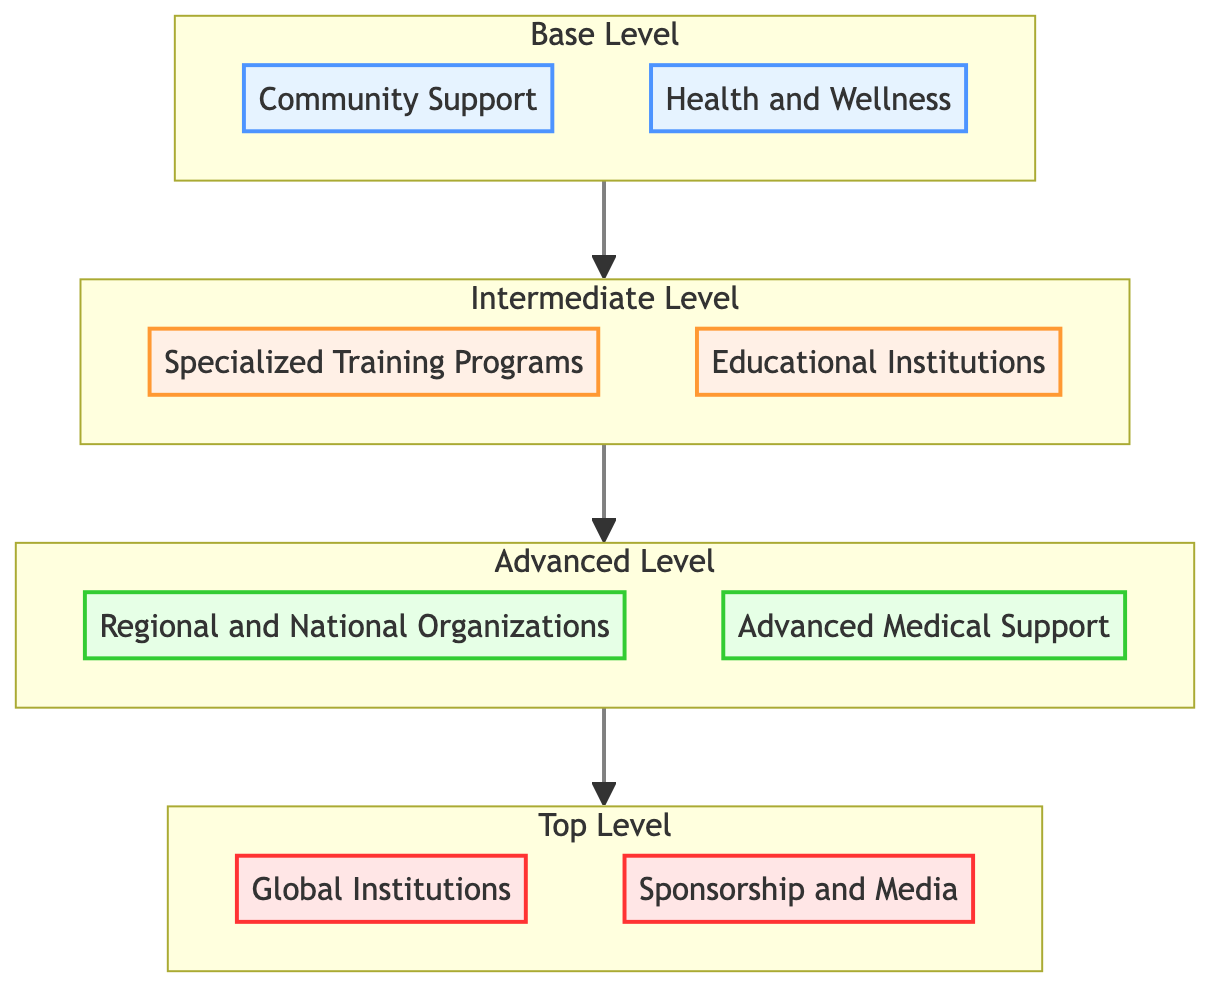What are the two categories at the Base Level? The Base Level consists of two categories, Community Support and Health and Wellness, as indicated in the diagram.
Answer: Community Support, Health and Wellness How many categories are there at the Advanced Level? The Advanced Level has two categories listed: Regional and National Organizations, and Advanced Medical Support. Counting these gives a total of two categories.
Answer: 2 What is the relationship between the Intermediate Level and the Top Level? The Intermediate Level feeds into the Top Level in a bottom-to-top flow, indicating that support systems at the Intermediate Level contribute to or lead to the systems at the Top Level.
Answer: Intermediate Level leads to Top Level Which support system is the topmost in the hierarchy? The Top Level contains Global Institutions and Sponsorship and Media. The topmost category, based on the diagram's hierarchy, is Global Institutions.
Answer: Global Institutions What type of support services are listed under Advanced Medical Support? The Advanced Medical Support includes three specific services: Sports Psychologists, Orthopedic Specialists, and Sports Nutritionists, as shown in the advanced level.
Answer: Sports Psychologists, Orthopedic Specialists, Sports Nutritionists How many distinct categories are present in the Intermediate Level? The Intermediate Level displays two distinct categories: Specialized Training Programs and Educational Institutions. Thus, there are two categories.
Answer: 2 Which category provides support through Corporate Sponsorships? The category that provides support through Corporate Sponsorships is found at the Top Level under Sponsorship and Media, indicating its role in providing financial backing.
Answer: Sponsorship and Media What flow direction is indicated in this diagram? The flow in the diagram is indicated to be bottom to top, as portrayed by the upwards-pointing arrows that guide the viewer's understanding of how support systems progress from the base to the top.
Answer: Bottom to Top What specialized support services are listed under the Regional and National Organizations? Under the Regional and National Organizations category, three specific organizations are mentioned: Special Olympics, Paralympic Committees, and National Governing Bodies for Adaptive Sports.
Answer: Special Olympics, Paralympic Committees, National Governing Bodies for Adaptive Sports 